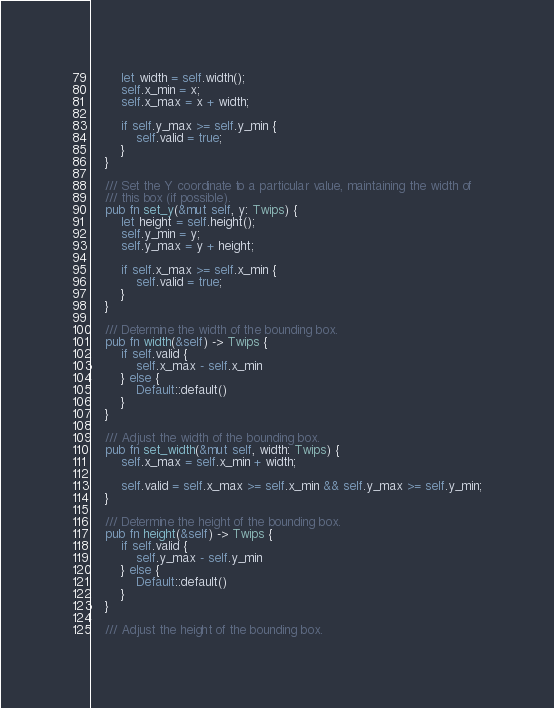Convert code to text. <code><loc_0><loc_0><loc_500><loc_500><_Rust_>        let width = self.width();
        self.x_min = x;
        self.x_max = x + width;

        if self.y_max >= self.y_min {
            self.valid = true;
        }
    }

    /// Set the Y coordinate to a particular value, maintaining the width of
    /// this box (if possible).
    pub fn set_y(&mut self, y: Twips) {
        let height = self.height();
        self.y_min = y;
        self.y_max = y + height;

        if self.x_max >= self.x_min {
            self.valid = true;
        }
    }

    /// Determine the width of the bounding box.
    pub fn width(&self) -> Twips {
        if self.valid {
            self.x_max - self.x_min
        } else {
            Default::default()
        }
    }

    /// Adjust the width of the bounding box.
    pub fn set_width(&mut self, width: Twips) {
        self.x_max = self.x_min + width;

        self.valid = self.x_max >= self.x_min && self.y_max >= self.y_min;
    }

    /// Determine the height of the bounding box.
    pub fn height(&self) -> Twips {
        if self.valid {
            self.y_max - self.y_min
        } else {
            Default::default()
        }
    }

    /// Adjust the height of the bounding box.</code> 